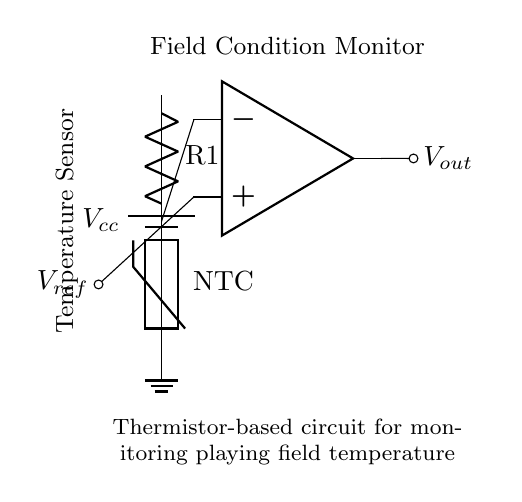What type of temperature sensor is used in this circuit? The circuit uses a thermistor, specifically a negative temperature coefficient (NTC) thermistor, which means its resistance decreases as the temperature increases. This is indicated in the diagram by the labeled thermistor component.
Answer: thermistor What is the purpose of the resistor connected to the thermistor? The resistor in parallel with the thermistor forms a voltage divider, which is used to create a reference voltage that can be compared at the op-amp. This is essential for measuring changes in temperature accurately by relating them to a corresponding output voltage.
Answer: voltage divider What component amplifies the signal in this circuit? The component that amplifies the signal is the operational amplifier (op-amp), which takes the voltage reading from the thermistor and resistor circuit and outputs a larger voltage proportional to the temperature change.
Answer: op-amp What is the reference voltage labeled in the circuit? The reference voltage, labeled as Vref, is the voltage at the non-inverting input of the op-amp. It serves as a baseline to compare against the input voltage to determine whether the output needs to increase or decrease based on the temperature sensor's reading.
Answer: Vref If the temperature increases, what happens to the resistance of the thermistor? As the temperature increases, the resistance of the thermistor decreases, which changes the voltage across the voltage divider, altering the input to the op-amp and leading to a higher output signal that reflects the increase in temperature.
Answer: decreases What is the function of the output voltage Vout in this circuit? The output voltage, Vout, represents the amplified signal indicating the temperature condition of the playing field. It is the output of the op-amp and reflects changes in temperature sensed by the thermistor primarily through changes in its resistance and the connected resistor's voltage.
Answer: Vout 